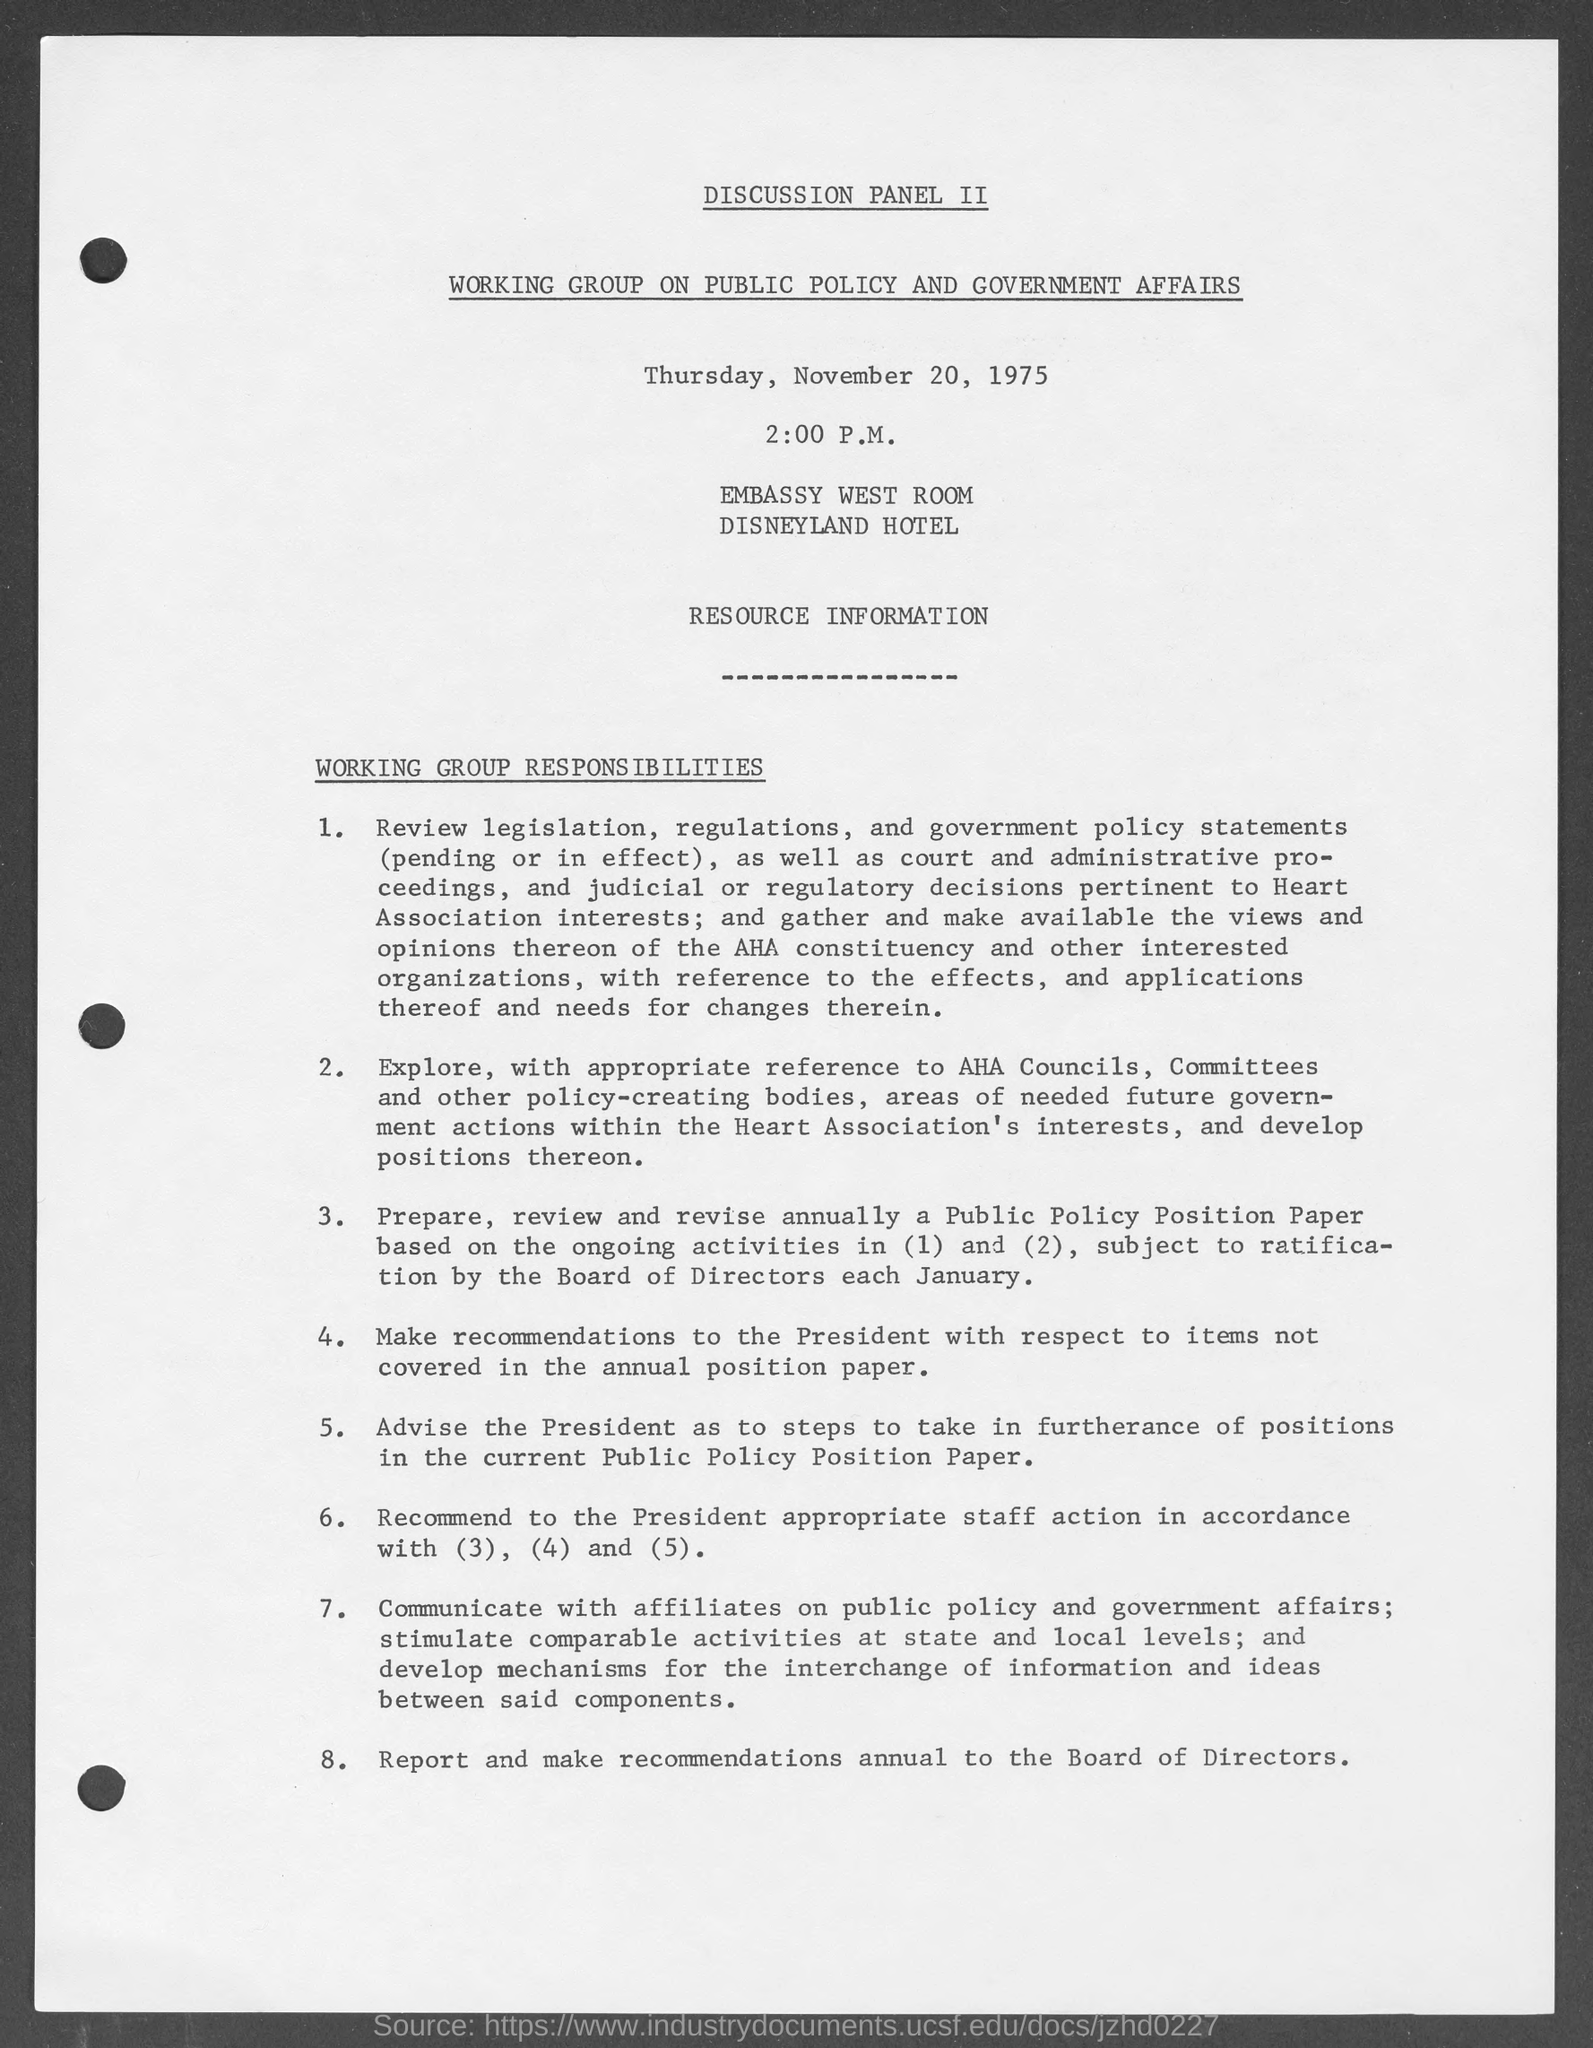Mention a couple of crucial points in this snapshot. The discussion panel II was working on a topic related to the working group on public policy and government affairs. The Disneyland hotel is mentioned in the given page, and its name is "Disneyland hotel. The discussion was taking place in the Embassy's west room. The date mentioned in the given page is November 20, 1975. 